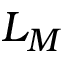<formula> <loc_0><loc_0><loc_500><loc_500>L _ { M }</formula> 